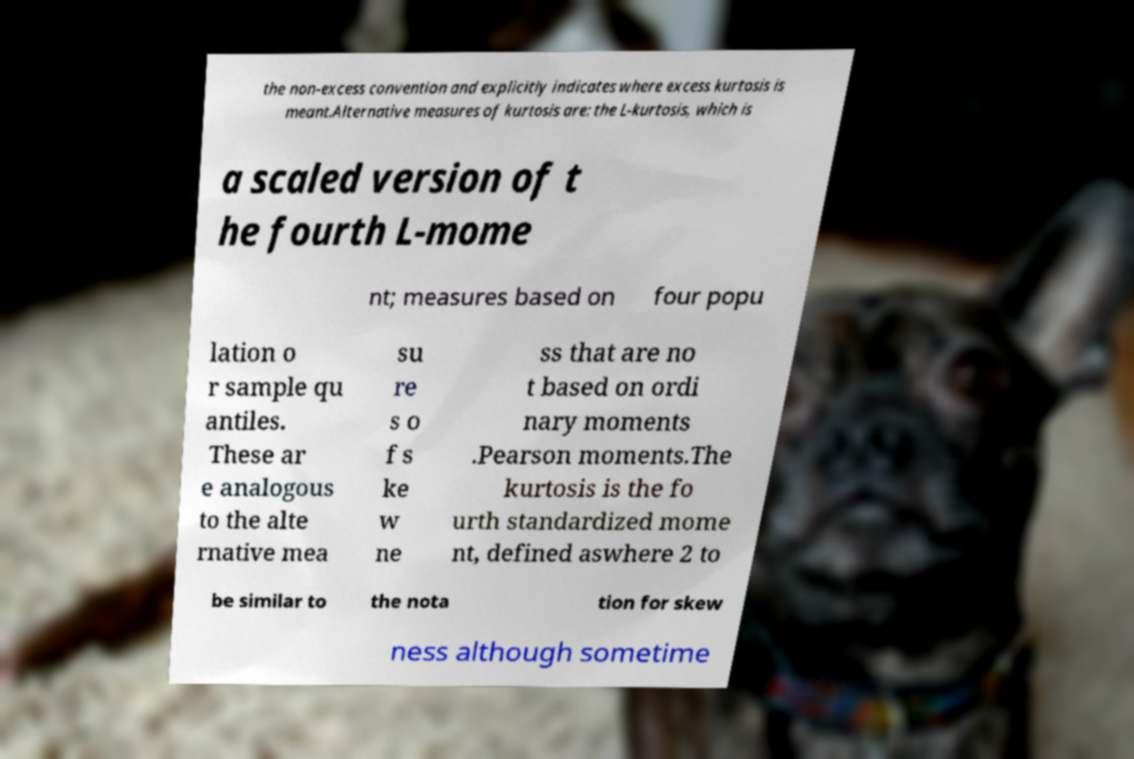Can you read and provide the text displayed in the image?This photo seems to have some interesting text. Can you extract and type it out for me? the non-excess convention and explicitly indicates where excess kurtosis is meant.Alternative measures of kurtosis are: the L-kurtosis, which is a scaled version of t he fourth L-mome nt; measures based on four popu lation o r sample qu antiles. These ar e analogous to the alte rnative mea su re s o f s ke w ne ss that are no t based on ordi nary moments .Pearson moments.The kurtosis is the fo urth standardized mome nt, defined aswhere 2 to be similar to the nota tion for skew ness although sometime 